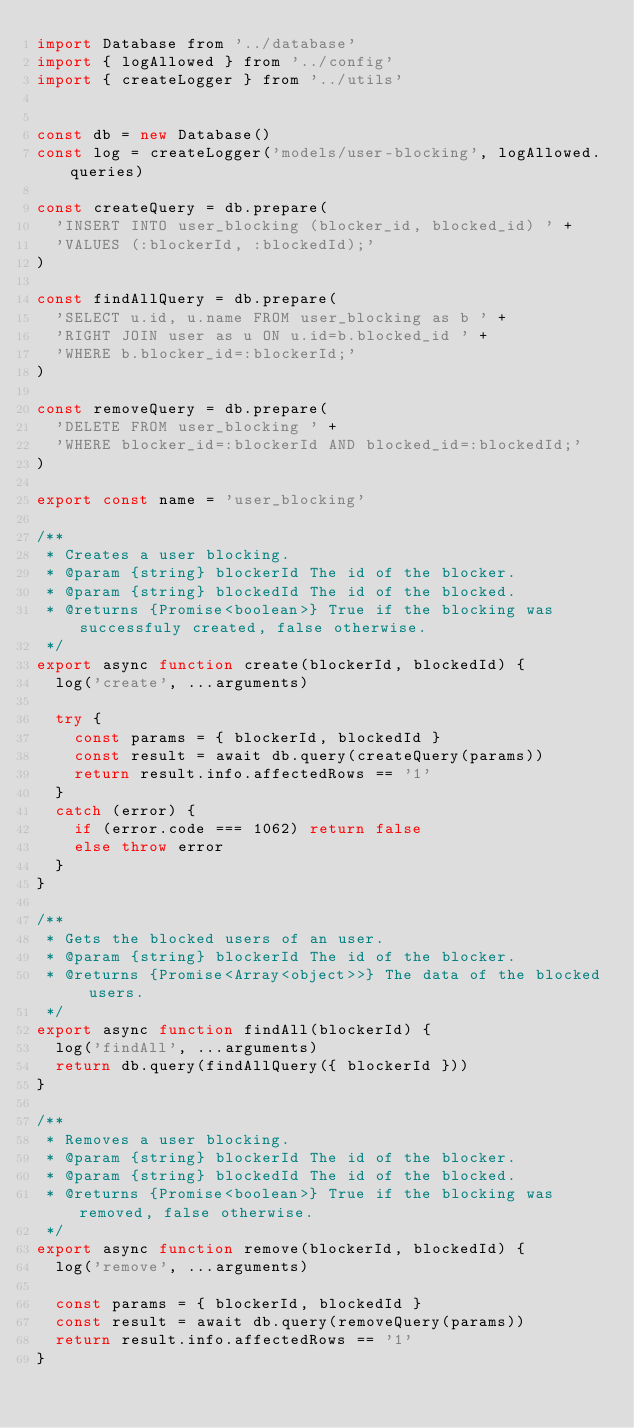Convert code to text. <code><loc_0><loc_0><loc_500><loc_500><_JavaScript_>import Database from '../database'
import { logAllowed } from '../config'
import { createLogger } from '../utils'


const db = new Database()
const log = createLogger('models/user-blocking', logAllowed.queries)

const createQuery = db.prepare(
  'INSERT INTO user_blocking (blocker_id, blocked_id) ' +
  'VALUES (:blockerId, :blockedId);'
)

const findAllQuery = db.prepare(
  'SELECT u.id, u.name FROM user_blocking as b ' +
  'RIGHT JOIN user as u ON u.id=b.blocked_id ' +
  'WHERE b.blocker_id=:blockerId;'
)

const removeQuery = db.prepare(
  'DELETE FROM user_blocking ' +
  'WHERE blocker_id=:blockerId AND blocked_id=:blockedId;'
)

export const name = 'user_blocking'

/**
 * Creates a user blocking.
 * @param {string} blockerId The id of the blocker.
 * @param {string} blockedId The id of the blocked.
 * @returns {Promise<boolean>} True if the blocking was successfuly created, false otherwise.
 */
export async function create(blockerId, blockedId) {
  log('create', ...arguments)

  try {
    const params = { blockerId, blockedId }
    const result = await db.query(createQuery(params))
    return result.info.affectedRows == '1'
  }
  catch (error) {
    if (error.code === 1062) return false
    else throw error
  }
}

/**
 * Gets the blocked users of an user.
 * @param {string} blockerId The id of the blocker.
 * @returns {Promise<Array<object>>} The data of the blocked users.
 */
export async function findAll(blockerId) {
  log('findAll', ...arguments)
  return db.query(findAllQuery({ blockerId }))
}

/**
 * Removes a user blocking.
 * @param {string} blockerId The id of the blocker.
 * @param {string} blockedId The id of the blocked.
 * @returns {Promise<boolean>} True if the blocking was removed, false otherwise.
 */
export async function remove(blockerId, blockedId) {
  log('remove', ...arguments)

  const params = { blockerId, blockedId }
  const result = await db.query(removeQuery(params))
  return result.info.affectedRows == '1'
}
</code> 